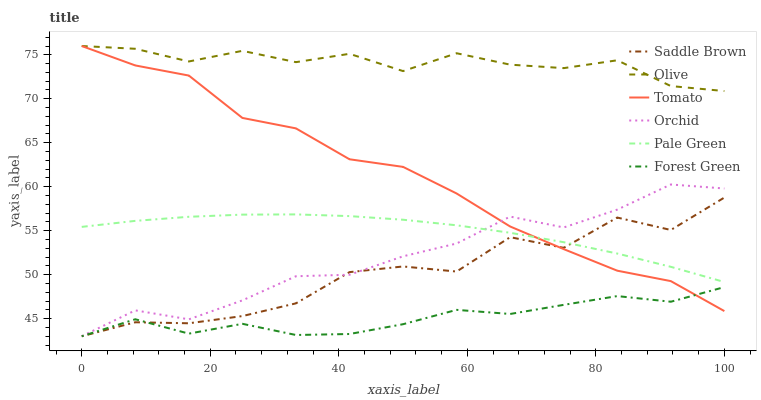Does Forest Green have the minimum area under the curve?
Answer yes or no. Yes. Does Olive have the maximum area under the curve?
Answer yes or no. Yes. Does Pale Green have the minimum area under the curve?
Answer yes or no. No. Does Pale Green have the maximum area under the curve?
Answer yes or no. No. Is Pale Green the smoothest?
Answer yes or no. Yes. Is Saddle Brown the roughest?
Answer yes or no. Yes. Is Forest Green the smoothest?
Answer yes or no. No. Is Forest Green the roughest?
Answer yes or no. No. Does Pale Green have the lowest value?
Answer yes or no. No. Does Olive have the highest value?
Answer yes or no. Yes. Does Pale Green have the highest value?
Answer yes or no. No. Is Forest Green less than Pale Green?
Answer yes or no. Yes. Is Olive greater than Saddle Brown?
Answer yes or no. Yes. Does Olive intersect Tomato?
Answer yes or no. Yes. Is Olive less than Tomato?
Answer yes or no. No. Is Olive greater than Tomato?
Answer yes or no. No. Does Forest Green intersect Pale Green?
Answer yes or no. No. 